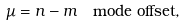Convert formula to latex. <formula><loc_0><loc_0><loc_500><loc_500>\mu & = n - m \quad \text {mode offset} ,</formula> 